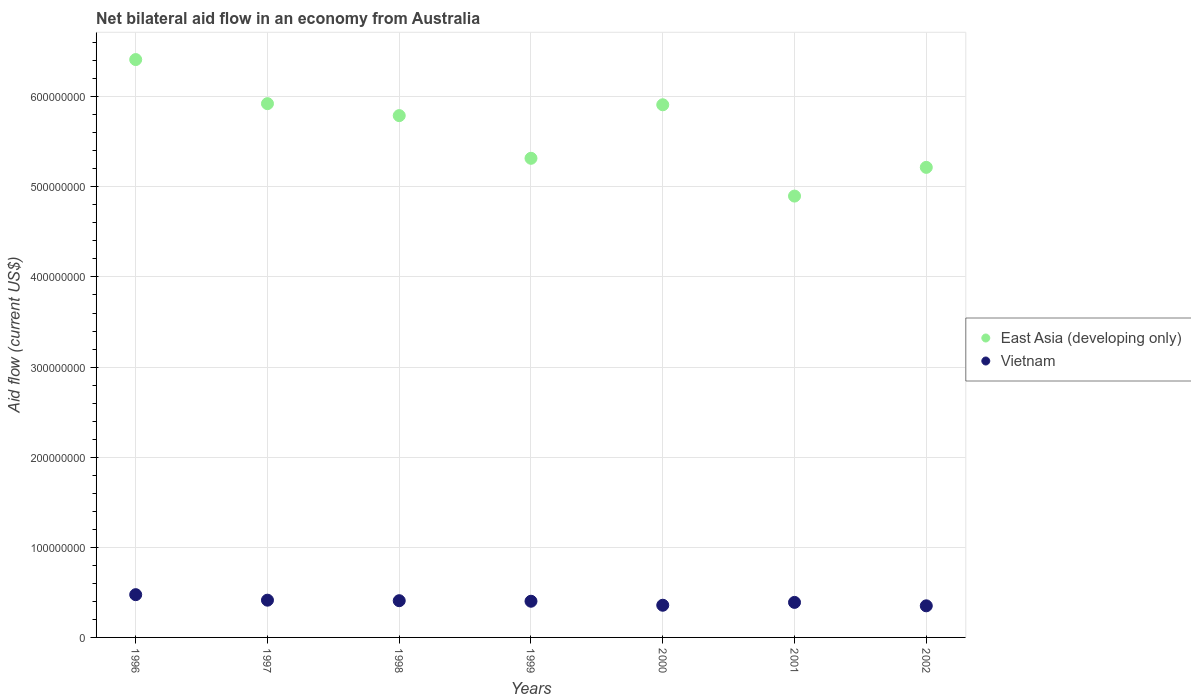How many different coloured dotlines are there?
Keep it short and to the point. 2. What is the net bilateral aid flow in East Asia (developing only) in 2000?
Ensure brevity in your answer.  5.91e+08. Across all years, what is the maximum net bilateral aid flow in East Asia (developing only)?
Ensure brevity in your answer.  6.41e+08. Across all years, what is the minimum net bilateral aid flow in East Asia (developing only)?
Keep it short and to the point. 4.90e+08. In which year was the net bilateral aid flow in East Asia (developing only) maximum?
Provide a short and direct response. 1996. In which year was the net bilateral aid flow in Vietnam minimum?
Offer a very short reply. 2002. What is the total net bilateral aid flow in Vietnam in the graph?
Keep it short and to the point. 2.79e+08. What is the difference between the net bilateral aid flow in East Asia (developing only) in 1999 and that in 2002?
Your answer should be compact. 1.01e+07. What is the difference between the net bilateral aid flow in Vietnam in 2001 and the net bilateral aid flow in East Asia (developing only) in 2000?
Ensure brevity in your answer.  -5.52e+08. What is the average net bilateral aid flow in Vietnam per year?
Make the answer very short. 3.99e+07. In the year 1996, what is the difference between the net bilateral aid flow in East Asia (developing only) and net bilateral aid flow in Vietnam?
Provide a succinct answer. 5.94e+08. What is the ratio of the net bilateral aid flow in East Asia (developing only) in 1998 to that in 2000?
Ensure brevity in your answer.  0.98. Is the net bilateral aid flow in East Asia (developing only) in 1996 less than that in 2002?
Offer a very short reply. No. Is the difference between the net bilateral aid flow in East Asia (developing only) in 2001 and 2002 greater than the difference between the net bilateral aid flow in Vietnam in 2001 and 2002?
Make the answer very short. No. What is the difference between the highest and the second highest net bilateral aid flow in East Asia (developing only)?
Make the answer very short. 4.89e+07. What is the difference between the highest and the lowest net bilateral aid flow in East Asia (developing only)?
Keep it short and to the point. 1.52e+08. Is the sum of the net bilateral aid flow in East Asia (developing only) in 1999 and 2000 greater than the maximum net bilateral aid flow in Vietnam across all years?
Provide a short and direct response. Yes. Is the net bilateral aid flow in Vietnam strictly greater than the net bilateral aid flow in East Asia (developing only) over the years?
Offer a very short reply. No. Is the net bilateral aid flow in East Asia (developing only) strictly less than the net bilateral aid flow in Vietnam over the years?
Offer a very short reply. No. How many dotlines are there?
Make the answer very short. 2. How many years are there in the graph?
Give a very brief answer. 7. What is the difference between two consecutive major ticks on the Y-axis?
Ensure brevity in your answer.  1.00e+08. Does the graph contain any zero values?
Ensure brevity in your answer.  No. How many legend labels are there?
Provide a succinct answer. 2. How are the legend labels stacked?
Your response must be concise. Vertical. What is the title of the graph?
Your answer should be very brief. Net bilateral aid flow in an economy from Australia. What is the label or title of the X-axis?
Make the answer very short. Years. What is the Aid flow (current US$) in East Asia (developing only) in 1996?
Your answer should be very brief. 6.41e+08. What is the Aid flow (current US$) in Vietnam in 1996?
Provide a short and direct response. 4.74e+07. What is the Aid flow (current US$) in East Asia (developing only) in 1997?
Keep it short and to the point. 5.92e+08. What is the Aid flow (current US$) in Vietnam in 1997?
Offer a very short reply. 4.13e+07. What is the Aid flow (current US$) of East Asia (developing only) in 1998?
Ensure brevity in your answer.  5.79e+08. What is the Aid flow (current US$) of Vietnam in 1998?
Give a very brief answer. 4.08e+07. What is the Aid flow (current US$) of East Asia (developing only) in 1999?
Keep it short and to the point. 5.32e+08. What is the Aid flow (current US$) in Vietnam in 1999?
Your answer should be very brief. 4.02e+07. What is the Aid flow (current US$) in East Asia (developing only) in 2000?
Your response must be concise. 5.91e+08. What is the Aid flow (current US$) in Vietnam in 2000?
Give a very brief answer. 3.57e+07. What is the Aid flow (current US$) in East Asia (developing only) in 2001?
Keep it short and to the point. 4.90e+08. What is the Aid flow (current US$) in Vietnam in 2001?
Keep it short and to the point. 3.89e+07. What is the Aid flow (current US$) of East Asia (developing only) in 2002?
Offer a very short reply. 5.22e+08. What is the Aid flow (current US$) in Vietnam in 2002?
Offer a very short reply. 3.51e+07. Across all years, what is the maximum Aid flow (current US$) in East Asia (developing only)?
Ensure brevity in your answer.  6.41e+08. Across all years, what is the maximum Aid flow (current US$) of Vietnam?
Make the answer very short. 4.74e+07. Across all years, what is the minimum Aid flow (current US$) of East Asia (developing only)?
Provide a succinct answer. 4.90e+08. Across all years, what is the minimum Aid flow (current US$) of Vietnam?
Your answer should be very brief. 3.51e+07. What is the total Aid flow (current US$) of East Asia (developing only) in the graph?
Give a very brief answer. 3.95e+09. What is the total Aid flow (current US$) in Vietnam in the graph?
Ensure brevity in your answer.  2.79e+08. What is the difference between the Aid flow (current US$) in East Asia (developing only) in 1996 and that in 1997?
Your response must be concise. 4.89e+07. What is the difference between the Aid flow (current US$) of Vietnam in 1996 and that in 1997?
Make the answer very short. 6.11e+06. What is the difference between the Aid flow (current US$) in East Asia (developing only) in 1996 and that in 1998?
Provide a short and direct response. 6.22e+07. What is the difference between the Aid flow (current US$) of Vietnam in 1996 and that in 1998?
Your response must be concise. 6.69e+06. What is the difference between the Aid flow (current US$) in East Asia (developing only) in 1996 and that in 1999?
Your response must be concise. 1.10e+08. What is the difference between the Aid flow (current US$) in Vietnam in 1996 and that in 1999?
Ensure brevity in your answer.  7.29e+06. What is the difference between the Aid flow (current US$) in East Asia (developing only) in 1996 and that in 2000?
Give a very brief answer. 5.02e+07. What is the difference between the Aid flow (current US$) of Vietnam in 1996 and that in 2000?
Give a very brief answer. 1.17e+07. What is the difference between the Aid flow (current US$) in East Asia (developing only) in 1996 and that in 2001?
Ensure brevity in your answer.  1.52e+08. What is the difference between the Aid flow (current US$) of Vietnam in 1996 and that in 2001?
Keep it short and to the point. 8.57e+06. What is the difference between the Aid flow (current US$) of East Asia (developing only) in 1996 and that in 2002?
Provide a short and direct response. 1.20e+08. What is the difference between the Aid flow (current US$) of Vietnam in 1996 and that in 2002?
Offer a terse response. 1.24e+07. What is the difference between the Aid flow (current US$) of East Asia (developing only) in 1997 and that in 1998?
Your answer should be very brief. 1.33e+07. What is the difference between the Aid flow (current US$) in Vietnam in 1997 and that in 1998?
Offer a very short reply. 5.80e+05. What is the difference between the Aid flow (current US$) of East Asia (developing only) in 1997 and that in 1999?
Your response must be concise. 6.06e+07. What is the difference between the Aid flow (current US$) in Vietnam in 1997 and that in 1999?
Your answer should be compact. 1.18e+06. What is the difference between the Aid flow (current US$) in East Asia (developing only) in 1997 and that in 2000?
Give a very brief answer. 1.25e+06. What is the difference between the Aid flow (current US$) in Vietnam in 1997 and that in 2000?
Give a very brief answer. 5.62e+06. What is the difference between the Aid flow (current US$) in East Asia (developing only) in 1997 and that in 2001?
Provide a succinct answer. 1.03e+08. What is the difference between the Aid flow (current US$) in Vietnam in 1997 and that in 2001?
Offer a very short reply. 2.46e+06. What is the difference between the Aid flow (current US$) in East Asia (developing only) in 1997 and that in 2002?
Ensure brevity in your answer.  7.07e+07. What is the difference between the Aid flow (current US$) of Vietnam in 1997 and that in 2002?
Make the answer very short. 6.27e+06. What is the difference between the Aid flow (current US$) in East Asia (developing only) in 1998 and that in 1999?
Provide a succinct answer. 4.74e+07. What is the difference between the Aid flow (current US$) of Vietnam in 1998 and that in 1999?
Ensure brevity in your answer.  6.00e+05. What is the difference between the Aid flow (current US$) in East Asia (developing only) in 1998 and that in 2000?
Make the answer very short. -1.20e+07. What is the difference between the Aid flow (current US$) in Vietnam in 1998 and that in 2000?
Keep it short and to the point. 5.04e+06. What is the difference between the Aid flow (current US$) of East Asia (developing only) in 1998 and that in 2001?
Your response must be concise. 8.93e+07. What is the difference between the Aid flow (current US$) of Vietnam in 1998 and that in 2001?
Ensure brevity in your answer.  1.88e+06. What is the difference between the Aid flow (current US$) in East Asia (developing only) in 1998 and that in 2002?
Your response must be concise. 5.74e+07. What is the difference between the Aid flow (current US$) of Vietnam in 1998 and that in 2002?
Offer a very short reply. 5.69e+06. What is the difference between the Aid flow (current US$) of East Asia (developing only) in 1999 and that in 2000?
Ensure brevity in your answer.  -5.94e+07. What is the difference between the Aid flow (current US$) in Vietnam in 1999 and that in 2000?
Offer a terse response. 4.44e+06. What is the difference between the Aid flow (current US$) of East Asia (developing only) in 1999 and that in 2001?
Make the answer very short. 4.19e+07. What is the difference between the Aid flow (current US$) of Vietnam in 1999 and that in 2001?
Your response must be concise. 1.28e+06. What is the difference between the Aid flow (current US$) of East Asia (developing only) in 1999 and that in 2002?
Keep it short and to the point. 1.01e+07. What is the difference between the Aid flow (current US$) in Vietnam in 1999 and that in 2002?
Your answer should be compact. 5.09e+06. What is the difference between the Aid flow (current US$) of East Asia (developing only) in 2000 and that in 2001?
Your answer should be compact. 1.01e+08. What is the difference between the Aid flow (current US$) of Vietnam in 2000 and that in 2001?
Give a very brief answer. -3.16e+06. What is the difference between the Aid flow (current US$) in East Asia (developing only) in 2000 and that in 2002?
Your answer should be compact. 6.95e+07. What is the difference between the Aid flow (current US$) of Vietnam in 2000 and that in 2002?
Provide a short and direct response. 6.50e+05. What is the difference between the Aid flow (current US$) of East Asia (developing only) in 2001 and that in 2002?
Offer a very short reply. -3.19e+07. What is the difference between the Aid flow (current US$) of Vietnam in 2001 and that in 2002?
Your answer should be compact. 3.81e+06. What is the difference between the Aid flow (current US$) of East Asia (developing only) in 1996 and the Aid flow (current US$) of Vietnam in 1997?
Your answer should be compact. 6.00e+08. What is the difference between the Aid flow (current US$) of East Asia (developing only) in 1996 and the Aid flow (current US$) of Vietnam in 1998?
Provide a short and direct response. 6.01e+08. What is the difference between the Aid flow (current US$) of East Asia (developing only) in 1996 and the Aid flow (current US$) of Vietnam in 1999?
Offer a very short reply. 6.01e+08. What is the difference between the Aid flow (current US$) in East Asia (developing only) in 1996 and the Aid flow (current US$) in Vietnam in 2000?
Your answer should be compact. 6.06e+08. What is the difference between the Aid flow (current US$) of East Asia (developing only) in 1996 and the Aid flow (current US$) of Vietnam in 2001?
Your answer should be compact. 6.02e+08. What is the difference between the Aid flow (current US$) of East Asia (developing only) in 1996 and the Aid flow (current US$) of Vietnam in 2002?
Provide a short and direct response. 6.06e+08. What is the difference between the Aid flow (current US$) in East Asia (developing only) in 1997 and the Aid flow (current US$) in Vietnam in 1998?
Your answer should be very brief. 5.52e+08. What is the difference between the Aid flow (current US$) in East Asia (developing only) in 1997 and the Aid flow (current US$) in Vietnam in 1999?
Provide a succinct answer. 5.52e+08. What is the difference between the Aid flow (current US$) in East Asia (developing only) in 1997 and the Aid flow (current US$) in Vietnam in 2000?
Offer a very short reply. 5.57e+08. What is the difference between the Aid flow (current US$) of East Asia (developing only) in 1997 and the Aid flow (current US$) of Vietnam in 2001?
Offer a terse response. 5.53e+08. What is the difference between the Aid flow (current US$) of East Asia (developing only) in 1997 and the Aid flow (current US$) of Vietnam in 2002?
Offer a very short reply. 5.57e+08. What is the difference between the Aid flow (current US$) of East Asia (developing only) in 1998 and the Aid flow (current US$) of Vietnam in 1999?
Your answer should be compact. 5.39e+08. What is the difference between the Aid flow (current US$) of East Asia (developing only) in 1998 and the Aid flow (current US$) of Vietnam in 2000?
Keep it short and to the point. 5.43e+08. What is the difference between the Aid flow (current US$) of East Asia (developing only) in 1998 and the Aid flow (current US$) of Vietnam in 2001?
Give a very brief answer. 5.40e+08. What is the difference between the Aid flow (current US$) in East Asia (developing only) in 1998 and the Aid flow (current US$) in Vietnam in 2002?
Give a very brief answer. 5.44e+08. What is the difference between the Aid flow (current US$) of East Asia (developing only) in 1999 and the Aid flow (current US$) of Vietnam in 2000?
Provide a short and direct response. 4.96e+08. What is the difference between the Aid flow (current US$) of East Asia (developing only) in 1999 and the Aid flow (current US$) of Vietnam in 2001?
Your answer should be very brief. 4.93e+08. What is the difference between the Aid flow (current US$) of East Asia (developing only) in 1999 and the Aid flow (current US$) of Vietnam in 2002?
Offer a very short reply. 4.97e+08. What is the difference between the Aid flow (current US$) in East Asia (developing only) in 2000 and the Aid flow (current US$) in Vietnam in 2001?
Offer a very short reply. 5.52e+08. What is the difference between the Aid flow (current US$) of East Asia (developing only) in 2000 and the Aid flow (current US$) of Vietnam in 2002?
Ensure brevity in your answer.  5.56e+08. What is the difference between the Aid flow (current US$) of East Asia (developing only) in 2001 and the Aid flow (current US$) of Vietnam in 2002?
Your response must be concise. 4.55e+08. What is the average Aid flow (current US$) in East Asia (developing only) per year?
Ensure brevity in your answer.  5.64e+08. What is the average Aid flow (current US$) of Vietnam per year?
Provide a succinct answer. 3.99e+07. In the year 1996, what is the difference between the Aid flow (current US$) in East Asia (developing only) and Aid flow (current US$) in Vietnam?
Provide a succinct answer. 5.94e+08. In the year 1997, what is the difference between the Aid flow (current US$) of East Asia (developing only) and Aid flow (current US$) of Vietnam?
Make the answer very short. 5.51e+08. In the year 1998, what is the difference between the Aid flow (current US$) of East Asia (developing only) and Aid flow (current US$) of Vietnam?
Make the answer very short. 5.38e+08. In the year 1999, what is the difference between the Aid flow (current US$) of East Asia (developing only) and Aid flow (current US$) of Vietnam?
Offer a very short reply. 4.92e+08. In the year 2000, what is the difference between the Aid flow (current US$) in East Asia (developing only) and Aid flow (current US$) in Vietnam?
Your response must be concise. 5.55e+08. In the year 2001, what is the difference between the Aid flow (current US$) of East Asia (developing only) and Aid flow (current US$) of Vietnam?
Offer a very short reply. 4.51e+08. In the year 2002, what is the difference between the Aid flow (current US$) of East Asia (developing only) and Aid flow (current US$) of Vietnam?
Offer a terse response. 4.87e+08. What is the ratio of the Aid flow (current US$) in East Asia (developing only) in 1996 to that in 1997?
Provide a succinct answer. 1.08. What is the ratio of the Aid flow (current US$) of Vietnam in 1996 to that in 1997?
Make the answer very short. 1.15. What is the ratio of the Aid flow (current US$) in East Asia (developing only) in 1996 to that in 1998?
Your response must be concise. 1.11. What is the ratio of the Aid flow (current US$) in Vietnam in 1996 to that in 1998?
Your response must be concise. 1.16. What is the ratio of the Aid flow (current US$) of East Asia (developing only) in 1996 to that in 1999?
Keep it short and to the point. 1.21. What is the ratio of the Aid flow (current US$) of Vietnam in 1996 to that in 1999?
Make the answer very short. 1.18. What is the ratio of the Aid flow (current US$) in East Asia (developing only) in 1996 to that in 2000?
Ensure brevity in your answer.  1.08. What is the ratio of the Aid flow (current US$) in Vietnam in 1996 to that in 2000?
Offer a very short reply. 1.33. What is the ratio of the Aid flow (current US$) of East Asia (developing only) in 1996 to that in 2001?
Your answer should be compact. 1.31. What is the ratio of the Aid flow (current US$) in Vietnam in 1996 to that in 2001?
Provide a short and direct response. 1.22. What is the ratio of the Aid flow (current US$) of East Asia (developing only) in 1996 to that in 2002?
Your response must be concise. 1.23. What is the ratio of the Aid flow (current US$) of Vietnam in 1996 to that in 2002?
Give a very brief answer. 1.35. What is the ratio of the Aid flow (current US$) of Vietnam in 1997 to that in 1998?
Offer a very short reply. 1.01. What is the ratio of the Aid flow (current US$) of East Asia (developing only) in 1997 to that in 1999?
Provide a short and direct response. 1.11. What is the ratio of the Aid flow (current US$) of Vietnam in 1997 to that in 1999?
Offer a terse response. 1.03. What is the ratio of the Aid flow (current US$) of Vietnam in 1997 to that in 2000?
Provide a short and direct response. 1.16. What is the ratio of the Aid flow (current US$) of East Asia (developing only) in 1997 to that in 2001?
Offer a very short reply. 1.21. What is the ratio of the Aid flow (current US$) in Vietnam in 1997 to that in 2001?
Give a very brief answer. 1.06. What is the ratio of the Aid flow (current US$) in East Asia (developing only) in 1997 to that in 2002?
Keep it short and to the point. 1.14. What is the ratio of the Aid flow (current US$) in Vietnam in 1997 to that in 2002?
Keep it short and to the point. 1.18. What is the ratio of the Aid flow (current US$) in East Asia (developing only) in 1998 to that in 1999?
Your response must be concise. 1.09. What is the ratio of the Aid flow (current US$) of Vietnam in 1998 to that in 1999?
Your response must be concise. 1.01. What is the ratio of the Aid flow (current US$) of East Asia (developing only) in 1998 to that in 2000?
Your response must be concise. 0.98. What is the ratio of the Aid flow (current US$) of Vietnam in 1998 to that in 2000?
Offer a terse response. 1.14. What is the ratio of the Aid flow (current US$) of East Asia (developing only) in 1998 to that in 2001?
Your answer should be very brief. 1.18. What is the ratio of the Aid flow (current US$) in Vietnam in 1998 to that in 2001?
Your response must be concise. 1.05. What is the ratio of the Aid flow (current US$) in East Asia (developing only) in 1998 to that in 2002?
Ensure brevity in your answer.  1.11. What is the ratio of the Aid flow (current US$) in Vietnam in 1998 to that in 2002?
Offer a very short reply. 1.16. What is the ratio of the Aid flow (current US$) in East Asia (developing only) in 1999 to that in 2000?
Your response must be concise. 0.9. What is the ratio of the Aid flow (current US$) in Vietnam in 1999 to that in 2000?
Keep it short and to the point. 1.12. What is the ratio of the Aid flow (current US$) of East Asia (developing only) in 1999 to that in 2001?
Give a very brief answer. 1.09. What is the ratio of the Aid flow (current US$) of Vietnam in 1999 to that in 2001?
Offer a terse response. 1.03. What is the ratio of the Aid flow (current US$) in East Asia (developing only) in 1999 to that in 2002?
Your response must be concise. 1.02. What is the ratio of the Aid flow (current US$) of Vietnam in 1999 to that in 2002?
Keep it short and to the point. 1.15. What is the ratio of the Aid flow (current US$) in East Asia (developing only) in 2000 to that in 2001?
Offer a very short reply. 1.21. What is the ratio of the Aid flow (current US$) in Vietnam in 2000 to that in 2001?
Your answer should be very brief. 0.92. What is the ratio of the Aid flow (current US$) of East Asia (developing only) in 2000 to that in 2002?
Provide a succinct answer. 1.13. What is the ratio of the Aid flow (current US$) in Vietnam in 2000 to that in 2002?
Make the answer very short. 1.02. What is the ratio of the Aid flow (current US$) in East Asia (developing only) in 2001 to that in 2002?
Provide a short and direct response. 0.94. What is the ratio of the Aid flow (current US$) of Vietnam in 2001 to that in 2002?
Offer a very short reply. 1.11. What is the difference between the highest and the second highest Aid flow (current US$) in East Asia (developing only)?
Ensure brevity in your answer.  4.89e+07. What is the difference between the highest and the second highest Aid flow (current US$) of Vietnam?
Provide a succinct answer. 6.11e+06. What is the difference between the highest and the lowest Aid flow (current US$) in East Asia (developing only)?
Give a very brief answer. 1.52e+08. What is the difference between the highest and the lowest Aid flow (current US$) of Vietnam?
Provide a short and direct response. 1.24e+07. 